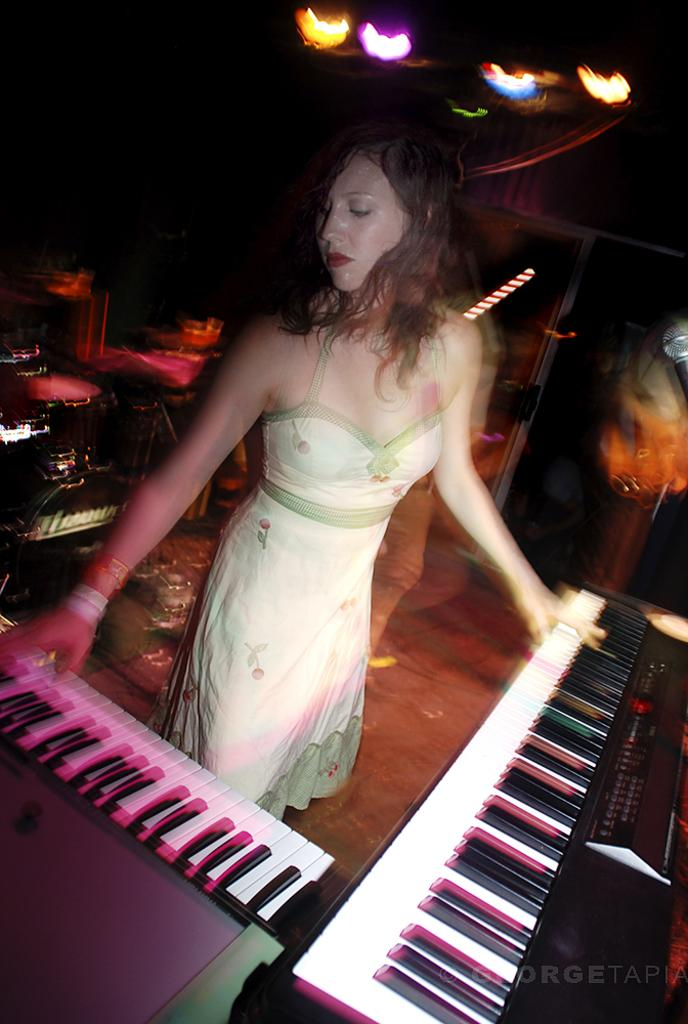What is the main subject in the image? There is a woman standing in the image. What can be seen in the background of the image? There is a piano and other objects visible in the background of the image. Can you describe the lighting in the image? There are lights visible in the image. How many brothers does the woman have, and what are their names? There is no information about the woman's brothers in the image, so we cannot determine their names or number. 